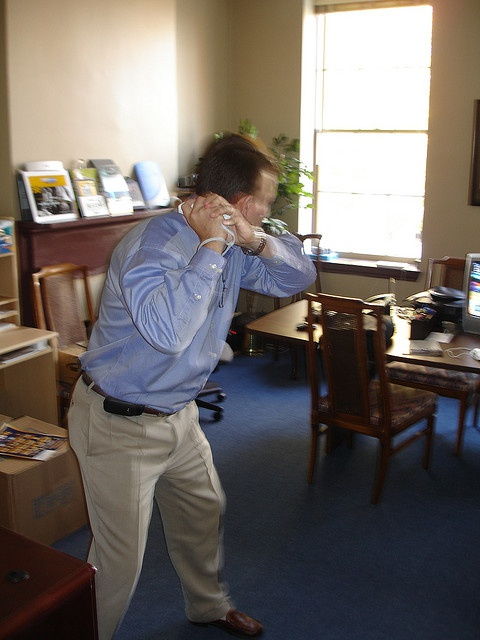Describe the objects in this image and their specific colors. I can see people in maroon, gray, darkgray, and black tones, chair in maroon, black, and navy tones, chair in maroon, gray, and brown tones, potted plant in maroon, black, darkgreen, gray, and white tones, and book in maroon, lightgray, darkgray, gray, and orange tones in this image. 